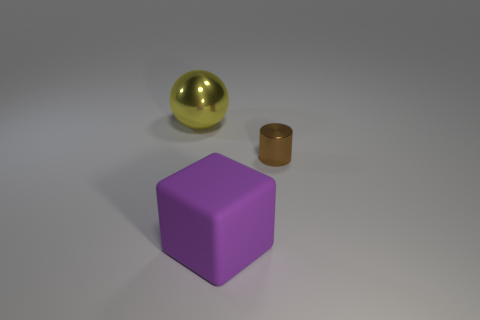Add 2 purple rubber cubes. How many objects exist? 5 Subtract all cubes. How many objects are left? 2 Subtract 0 cyan cylinders. How many objects are left? 3 Subtract all big purple rubber blocks. Subtract all yellow balls. How many objects are left? 1 Add 1 big purple matte cubes. How many big purple matte cubes are left? 2 Add 3 small red cylinders. How many small red cylinders exist? 3 